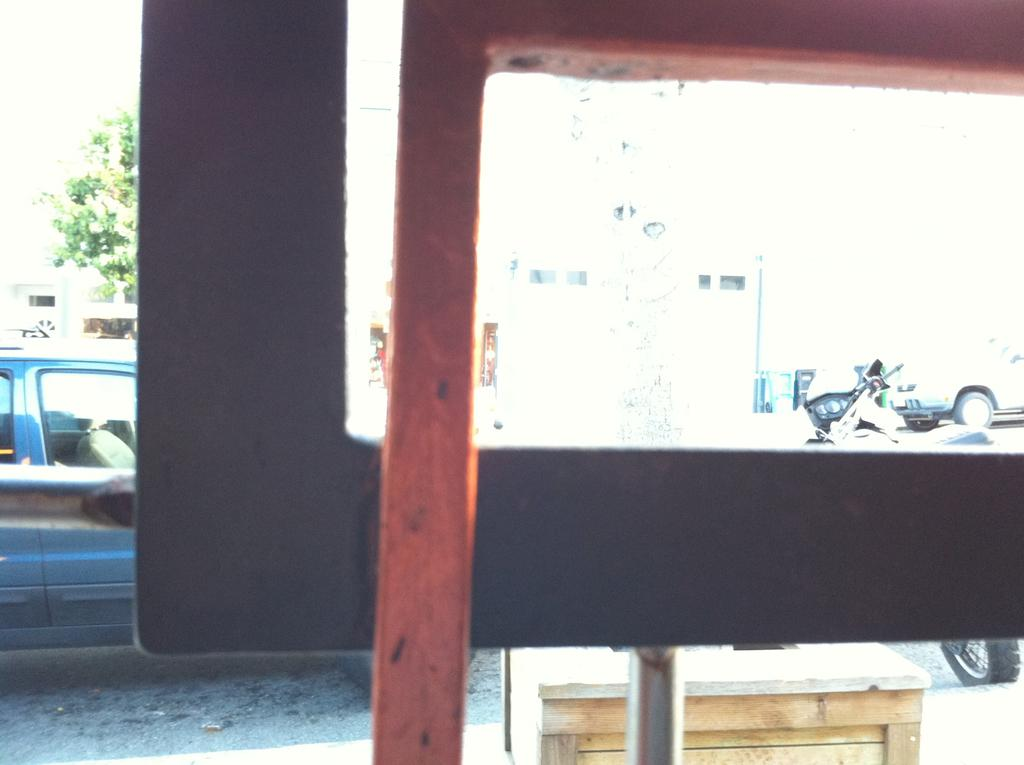What can be seen on the road in the image? There are vehicles on the road in the image. What is located in the foreground of the image? There is a metal rod in the foreground of the image. What type of structure is visible in the background of the image? There is a building with windows in the background of the image. What else can be seen in the background of the image? There is a pole and a tree in the background of the image. Can you hear the spy sneezing in the image? There is no indication of a spy or sneezing in the image; it features vehicles on the road, a metal rod in the foreground, and a building, pole, and tree in the background. 